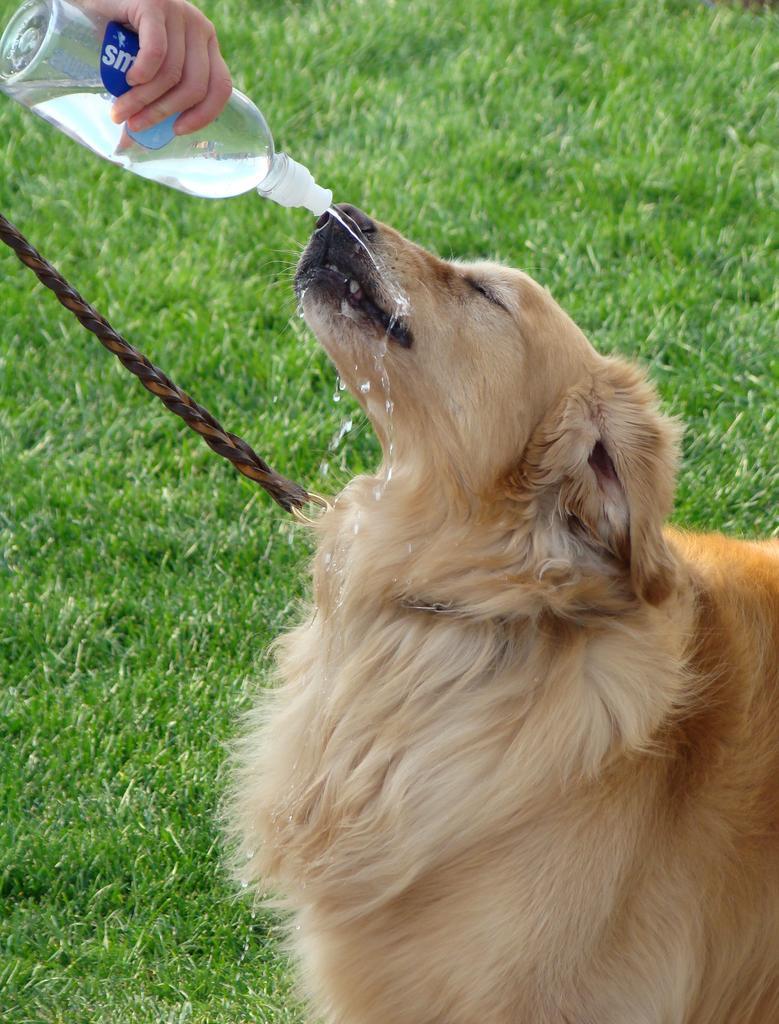In one or two sentences, can you explain what this image depicts? In this picture there is a dog and person is holding a water bottle. 